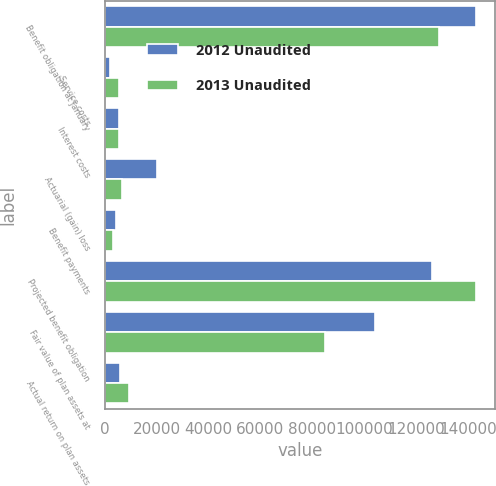Convert chart to OTSL. <chart><loc_0><loc_0><loc_500><loc_500><stacked_bar_chart><ecel><fcel>Benefit obligation at January<fcel>Service costs<fcel>Interest costs<fcel>Actuarial (gain) loss<fcel>Benefit payments<fcel>Projected benefit obligation<fcel>Fair value of plan assets at<fcel>Actual return on plan assets<nl><fcel>2012 Unaudited<fcel>143158<fcel>1977<fcel>5639<fcel>20313<fcel>4427<fcel>126034<fcel>104242<fcel>5785<nl><fcel>2013 Unaudited<fcel>128567<fcel>5707<fcel>5413<fcel>6560<fcel>3089<fcel>143158<fcel>84751<fcel>9480<nl></chart> 